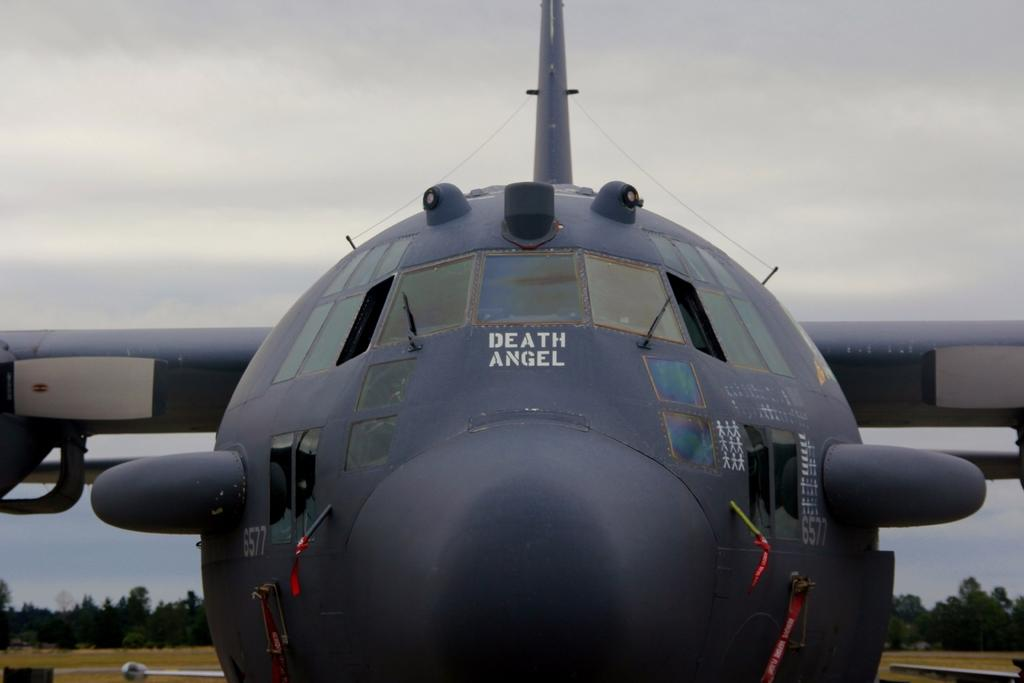What is the main subject of the image? The main subject of the image is an airplane. What can be seen in the background of the image? There are trees and the sky visible in the background of the image. Can you see any ghosts in the image? No, there are no ghosts present in the image. What type of twist is visible in the image? There is no twist visible in the image; it features an airplane and a background with trees and the sky. 